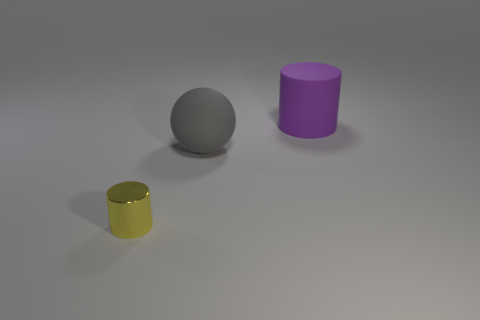How does the arrangement of objects contribute to the composition of this image? The arrangement of objects creates a balanced composition. The placement of the yellow metallic cylinder in front, with the purple cylinder slightly behind and to the left, and the sphere to its right, forms a triangular layout that guides the viewer's eye through the scene. This setup not only provides visual interest but also a sense of depth and dimension. 